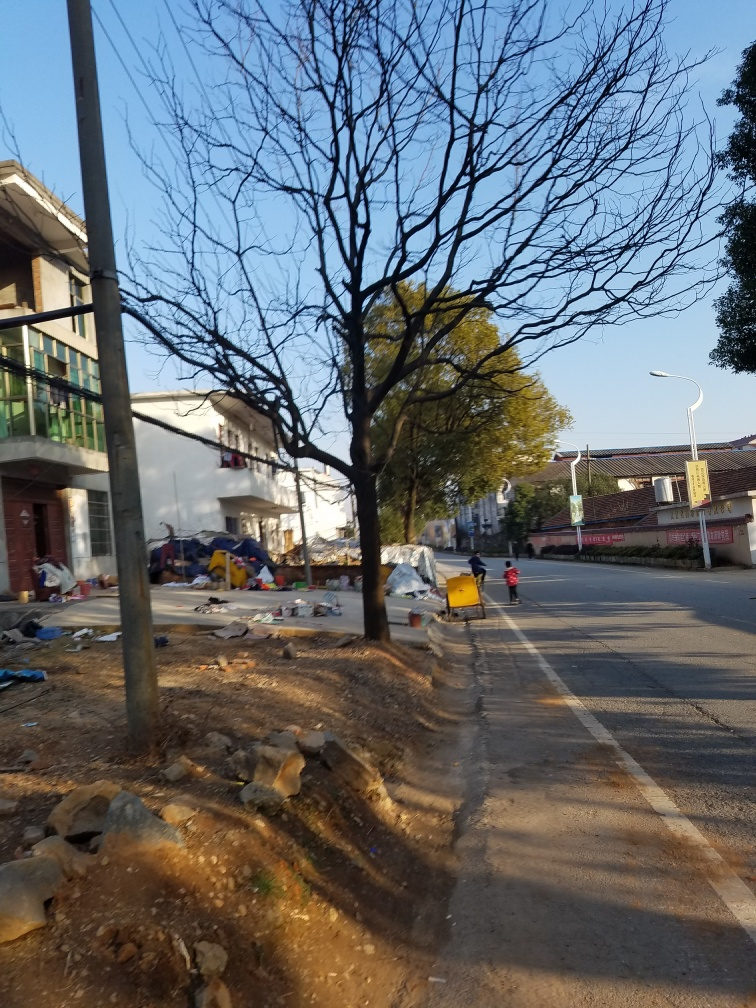Is the overall clarity of the image good?
A. Yes
B. No
Answer with the option's letter from the given choices directly.
 A. 